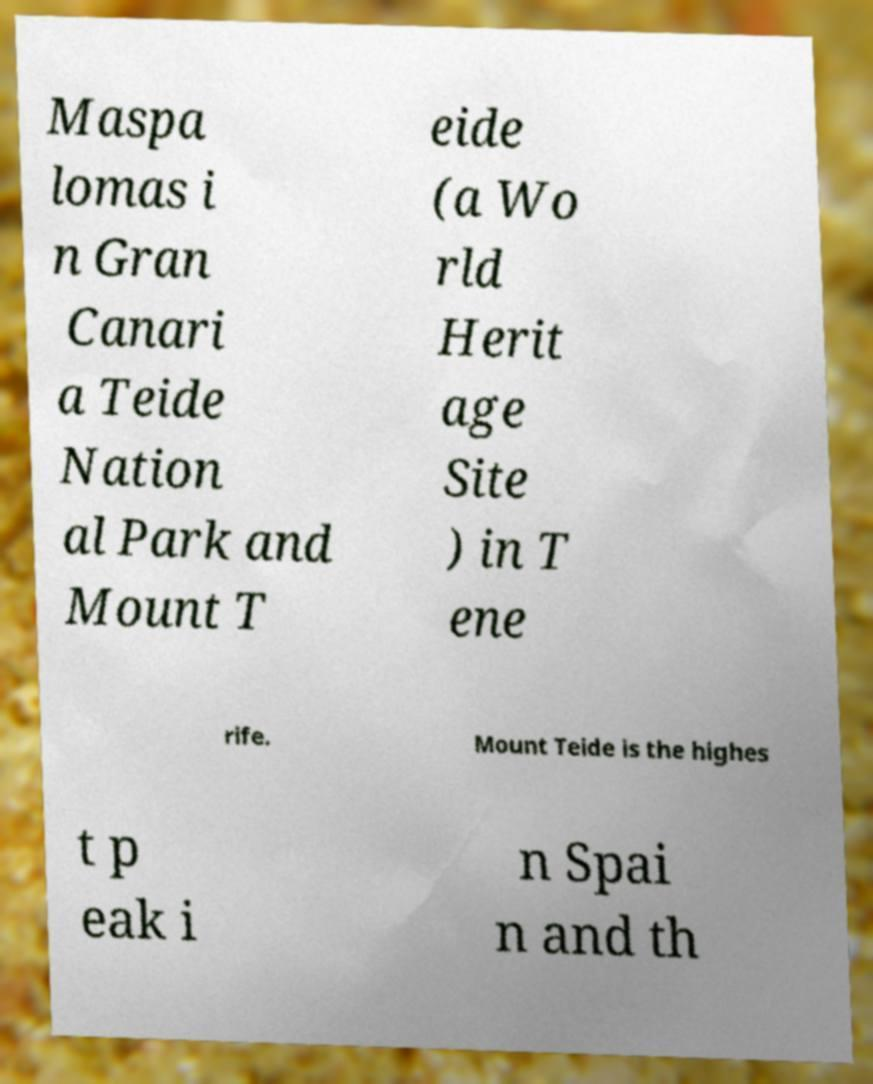Please identify and transcribe the text found in this image. Maspa lomas i n Gran Canari a Teide Nation al Park and Mount T eide (a Wo rld Herit age Site ) in T ene rife. Mount Teide is the highes t p eak i n Spai n and th 